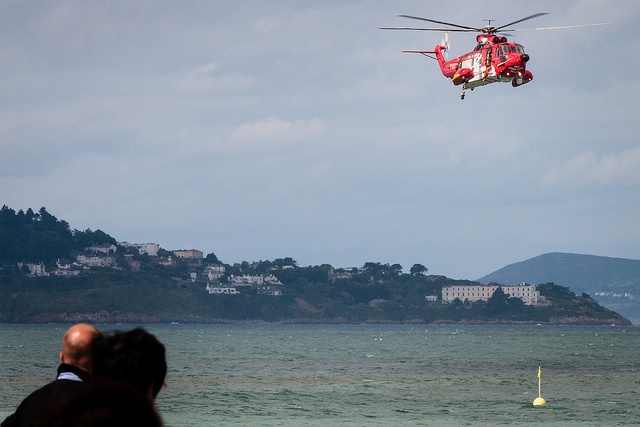Describe the objects in this image and their specific colors. I can see people in darkgray, black, gray, purple, and darkblue tones and people in darkgray, black, maroon, gray, and brown tones in this image. 